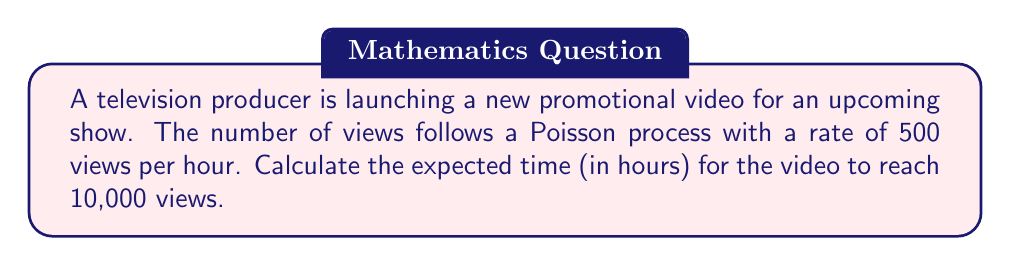Show me your answer to this math problem. To solve this problem, we'll use properties of the Poisson process:

1) In a Poisson process, the time between events follows an exponential distribution.

2) The sum of exponentially distributed random variables follows an Erlang distribution.

3) The number of views we're waiting for (10,000) can be thought of as the 10,000th event in the Poisson process.

4) For an Erlang distribution with shape parameter $k$ and rate parameter $\lambda$, the expected value is $\frac{k}{\lambda}$.

In this case:
- $k = 10,000$ (number of views we're waiting for)
- $\lambda = 500$ views per hour

Therefore, the expected time $E[T]$ to reach 10,000 views is:

$$E[T] = \frac{k}{\lambda} = \frac{10,000}{500} = 20$$

This means we expect it to take 20 hours for the promotional video to reach 10,000 views.
Answer: 20 hours 